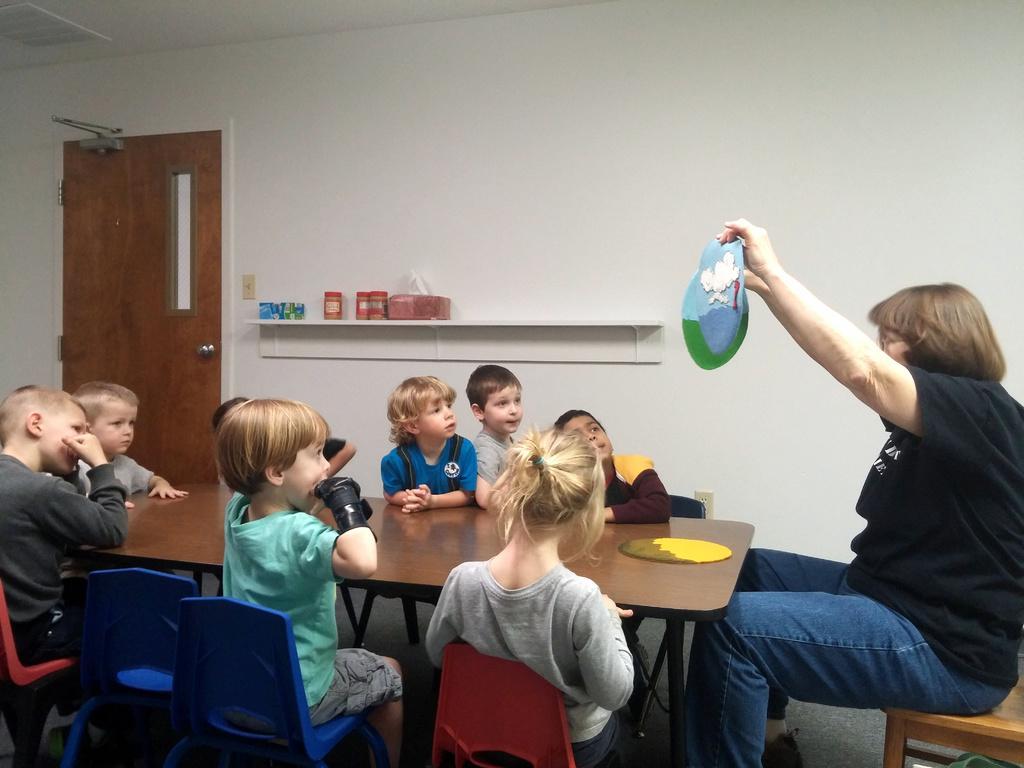Describe this image in one or two sentences. These kids are sitting on a chair. In-front of his kids there is a table. This woman is sitting on a chair and holding a cloth. On this rack there are jars. This is door with handle. 